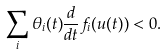Convert formula to latex. <formula><loc_0><loc_0><loc_500><loc_500>\sum _ { i } \theta _ { i } ( t ) \frac { d } { d t } f _ { i } ( u ( t ) ) < 0 .</formula> 